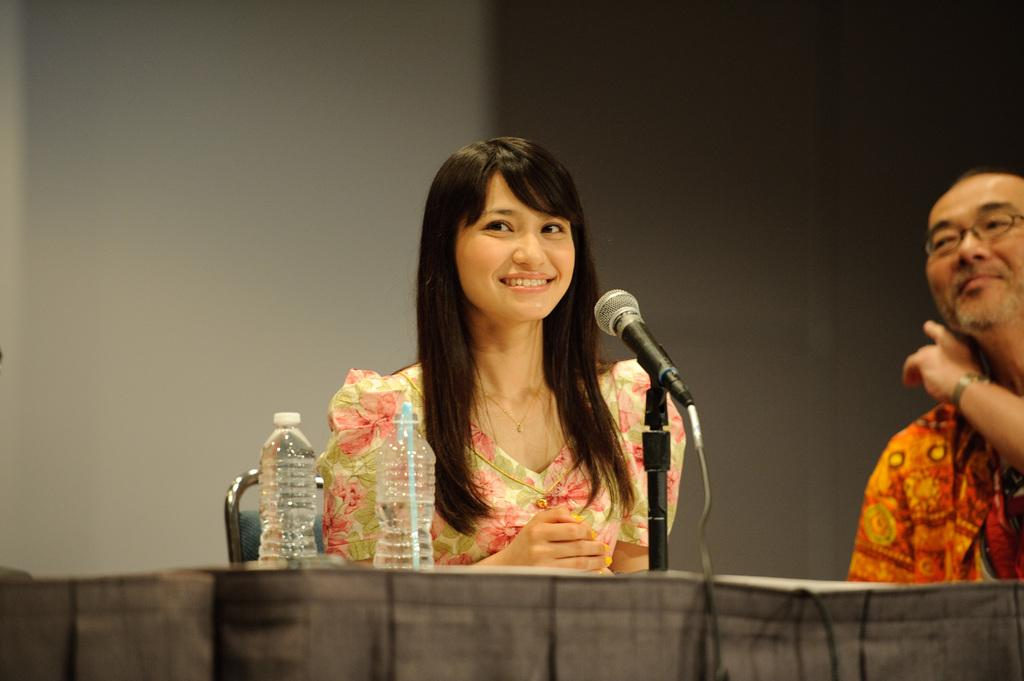How many people are in the image? There are two people in the image, a woman and a man. What are the woman and the man doing in the image? Both the woman and the man are sitting on chairs. What is the facial expression of the woman in the image? The woman is smiling. What objects can be seen on the table in the image? There are bottles and a microphone (mic) on the table. What type of fowl can be seen playing with a toy in the image? There is no fowl or toy present in the image; it features a woman, a man, and objects on a table. Can you tell me how many chickens are depicted in the image? There are no chickens depicted in the image. 